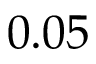Convert formula to latex. <formula><loc_0><loc_0><loc_500><loc_500>0 . 0 5</formula> 